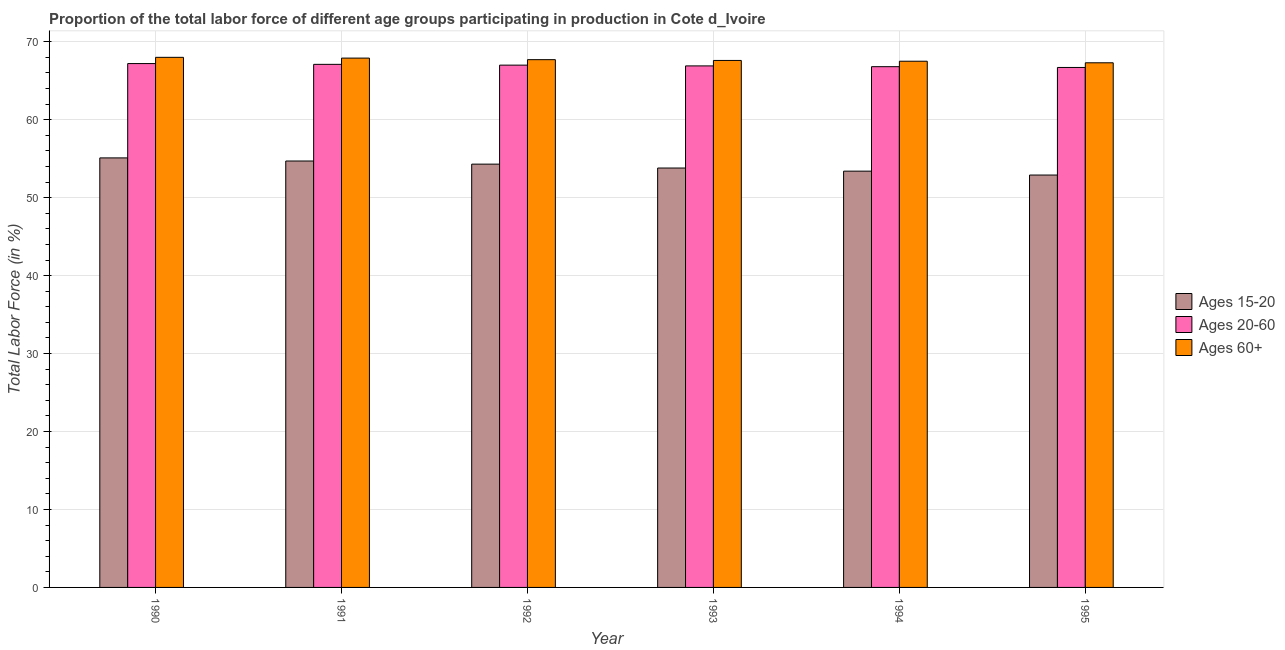Are the number of bars per tick equal to the number of legend labels?
Your response must be concise. Yes. How many bars are there on the 6th tick from the left?
Your answer should be compact. 3. In how many cases, is the number of bars for a given year not equal to the number of legend labels?
Your answer should be very brief. 0. What is the percentage of labor force within the age group 15-20 in 1994?
Keep it short and to the point. 53.4. Across all years, what is the maximum percentage of labor force within the age group 20-60?
Provide a short and direct response. 67.2. Across all years, what is the minimum percentage of labor force above age 60?
Your answer should be compact. 67.3. What is the total percentage of labor force within the age group 15-20 in the graph?
Your answer should be compact. 324.2. What is the difference between the percentage of labor force within the age group 15-20 in 1990 and that in 1994?
Offer a very short reply. 1.7. What is the difference between the percentage of labor force above age 60 in 1991 and the percentage of labor force within the age group 20-60 in 1992?
Provide a short and direct response. 0.2. What is the average percentage of labor force above age 60 per year?
Offer a very short reply. 67.67. In how many years, is the percentage of labor force above age 60 greater than 32 %?
Your response must be concise. 6. What is the ratio of the percentage of labor force above age 60 in 1993 to that in 1994?
Offer a very short reply. 1. Is the percentage of labor force within the age group 20-60 in 1991 less than that in 1993?
Offer a terse response. No. What is the difference between the highest and the second highest percentage of labor force above age 60?
Ensure brevity in your answer.  0.1. What is the difference between the highest and the lowest percentage of labor force within the age group 15-20?
Make the answer very short. 2.2. In how many years, is the percentage of labor force within the age group 15-20 greater than the average percentage of labor force within the age group 15-20 taken over all years?
Offer a very short reply. 3. Is the sum of the percentage of labor force within the age group 20-60 in 1994 and 1995 greater than the maximum percentage of labor force within the age group 15-20 across all years?
Ensure brevity in your answer.  Yes. What does the 2nd bar from the left in 1994 represents?
Ensure brevity in your answer.  Ages 20-60. What does the 1st bar from the right in 1994 represents?
Ensure brevity in your answer.  Ages 60+. How many years are there in the graph?
Your answer should be compact. 6. Are the values on the major ticks of Y-axis written in scientific E-notation?
Keep it short and to the point. No. Does the graph contain any zero values?
Offer a very short reply. No. Does the graph contain grids?
Give a very brief answer. Yes. How many legend labels are there?
Offer a very short reply. 3. How are the legend labels stacked?
Your answer should be very brief. Vertical. What is the title of the graph?
Ensure brevity in your answer.  Proportion of the total labor force of different age groups participating in production in Cote d_Ivoire. What is the label or title of the X-axis?
Offer a terse response. Year. What is the Total Labor Force (in %) in Ages 15-20 in 1990?
Offer a terse response. 55.1. What is the Total Labor Force (in %) of Ages 20-60 in 1990?
Provide a short and direct response. 67.2. What is the Total Labor Force (in %) in Ages 60+ in 1990?
Your answer should be compact. 68. What is the Total Labor Force (in %) in Ages 15-20 in 1991?
Provide a succinct answer. 54.7. What is the Total Labor Force (in %) of Ages 20-60 in 1991?
Offer a very short reply. 67.1. What is the Total Labor Force (in %) in Ages 60+ in 1991?
Keep it short and to the point. 67.9. What is the Total Labor Force (in %) of Ages 15-20 in 1992?
Make the answer very short. 54.3. What is the Total Labor Force (in %) of Ages 20-60 in 1992?
Offer a terse response. 67. What is the Total Labor Force (in %) of Ages 60+ in 1992?
Make the answer very short. 67.7. What is the Total Labor Force (in %) of Ages 15-20 in 1993?
Offer a very short reply. 53.8. What is the Total Labor Force (in %) in Ages 20-60 in 1993?
Ensure brevity in your answer.  66.9. What is the Total Labor Force (in %) in Ages 60+ in 1993?
Provide a succinct answer. 67.6. What is the Total Labor Force (in %) of Ages 15-20 in 1994?
Provide a succinct answer. 53.4. What is the Total Labor Force (in %) in Ages 20-60 in 1994?
Your answer should be very brief. 66.8. What is the Total Labor Force (in %) in Ages 60+ in 1994?
Your answer should be compact. 67.5. What is the Total Labor Force (in %) of Ages 15-20 in 1995?
Your answer should be compact. 52.9. What is the Total Labor Force (in %) in Ages 20-60 in 1995?
Your answer should be very brief. 66.7. What is the Total Labor Force (in %) of Ages 60+ in 1995?
Keep it short and to the point. 67.3. Across all years, what is the maximum Total Labor Force (in %) in Ages 15-20?
Ensure brevity in your answer.  55.1. Across all years, what is the maximum Total Labor Force (in %) of Ages 20-60?
Keep it short and to the point. 67.2. Across all years, what is the minimum Total Labor Force (in %) of Ages 15-20?
Your response must be concise. 52.9. Across all years, what is the minimum Total Labor Force (in %) of Ages 20-60?
Your response must be concise. 66.7. Across all years, what is the minimum Total Labor Force (in %) in Ages 60+?
Give a very brief answer. 67.3. What is the total Total Labor Force (in %) in Ages 15-20 in the graph?
Make the answer very short. 324.2. What is the total Total Labor Force (in %) of Ages 20-60 in the graph?
Make the answer very short. 401.7. What is the total Total Labor Force (in %) of Ages 60+ in the graph?
Offer a very short reply. 406. What is the difference between the Total Labor Force (in %) of Ages 15-20 in 1990 and that in 1991?
Your response must be concise. 0.4. What is the difference between the Total Labor Force (in %) of Ages 60+ in 1990 and that in 1991?
Your answer should be compact. 0.1. What is the difference between the Total Labor Force (in %) of Ages 15-20 in 1990 and that in 1992?
Make the answer very short. 0.8. What is the difference between the Total Labor Force (in %) of Ages 60+ in 1990 and that in 1992?
Provide a succinct answer. 0.3. What is the difference between the Total Labor Force (in %) in Ages 15-20 in 1990 and that in 1993?
Make the answer very short. 1.3. What is the difference between the Total Labor Force (in %) of Ages 60+ in 1990 and that in 1993?
Make the answer very short. 0.4. What is the difference between the Total Labor Force (in %) of Ages 15-20 in 1990 and that in 1994?
Make the answer very short. 1.7. What is the difference between the Total Labor Force (in %) of Ages 15-20 in 1990 and that in 1995?
Make the answer very short. 2.2. What is the difference between the Total Labor Force (in %) of Ages 20-60 in 1990 and that in 1995?
Provide a short and direct response. 0.5. What is the difference between the Total Labor Force (in %) in Ages 20-60 in 1991 and that in 1992?
Your response must be concise. 0.1. What is the difference between the Total Labor Force (in %) in Ages 60+ in 1991 and that in 1992?
Your answer should be very brief. 0.2. What is the difference between the Total Labor Force (in %) in Ages 15-20 in 1991 and that in 1993?
Provide a short and direct response. 0.9. What is the difference between the Total Labor Force (in %) of Ages 20-60 in 1991 and that in 1993?
Your response must be concise. 0.2. What is the difference between the Total Labor Force (in %) in Ages 60+ in 1991 and that in 1993?
Your response must be concise. 0.3. What is the difference between the Total Labor Force (in %) of Ages 60+ in 1991 and that in 1994?
Provide a succinct answer. 0.4. What is the difference between the Total Labor Force (in %) in Ages 20-60 in 1991 and that in 1995?
Ensure brevity in your answer.  0.4. What is the difference between the Total Labor Force (in %) in Ages 60+ in 1992 and that in 1993?
Ensure brevity in your answer.  0.1. What is the difference between the Total Labor Force (in %) in Ages 20-60 in 1992 and that in 1994?
Your answer should be very brief. 0.2. What is the difference between the Total Labor Force (in %) of Ages 60+ in 1992 and that in 1995?
Give a very brief answer. 0.4. What is the difference between the Total Labor Force (in %) of Ages 20-60 in 1993 and that in 1994?
Offer a terse response. 0.1. What is the difference between the Total Labor Force (in %) of Ages 20-60 in 1993 and that in 1995?
Your answer should be very brief. 0.2. What is the difference between the Total Labor Force (in %) in Ages 15-20 in 1990 and the Total Labor Force (in %) in Ages 20-60 in 1991?
Your answer should be compact. -12. What is the difference between the Total Labor Force (in %) in Ages 20-60 in 1990 and the Total Labor Force (in %) in Ages 60+ in 1991?
Your response must be concise. -0.7. What is the difference between the Total Labor Force (in %) in Ages 15-20 in 1990 and the Total Labor Force (in %) in Ages 20-60 in 1993?
Make the answer very short. -11.8. What is the difference between the Total Labor Force (in %) in Ages 15-20 in 1990 and the Total Labor Force (in %) in Ages 60+ in 1993?
Offer a terse response. -12.5. What is the difference between the Total Labor Force (in %) in Ages 20-60 in 1990 and the Total Labor Force (in %) in Ages 60+ in 1993?
Keep it short and to the point. -0.4. What is the difference between the Total Labor Force (in %) in Ages 15-20 in 1990 and the Total Labor Force (in %) in Ages 20-60 in 1995?
Provide a short and direct response. -11.6. What is the difference between the Total Labor Force (in %) in Ages 15-20 in 1990 and the Total Labor Force (in %) in Ages 60+ in 1995?
Offer a terse response. -12.2. What is the difference between the Total Labor Force (in %) in Ages 20-60 in 1990 and the Total Labor Force (in %) in Ages 60+ in 1995?
Your response must be concise. -0.1. What is the difference between the Total Labor Force (in %) in Ages 20-60 in 1991 and the Total Labor Force (in %) in Ages 60+ in 1993?
Provide a succinct answer. -0.5. What is the difference between the Total Labor Force (in %) of Ages 15-20 in 1991 and the Total Labor Force (in %) of Ages 20-60 in 1994?
Provide a short and direct response. -12.1. What is the difference between the Total Labor Force (in %) of Ages 15-20 in 1991 and the Total Labor Force (in %) of Ages 60+ in 1994?
Your answer should be compact. -12.8. What is the difference between the Total Labor Force (in %) of Ages 15-20 in 1991 and the Total Labor Force (in %) of Ages 20-60 in 1995?
Provide a succinct answer. -12. What is the difference between the Total Labor Force (in %) of Ages 15-20 in 1991 and the Total Labor Force (in %) of Ages 60+ in 1995?
Your answer should be compact. -12.6. What is the difference between the Total Labor Force (in %) in Ages 20-60 in 1991 and the Total Labor Force (in %) in Ages 60+ in 1995?
Offer a very short reply. -0.2. What is the difference between the Total Labor Force (in %) of Ages 15-20 in 1992 and the Total Labor Force (in %) of Ages 60+ in 1993?
Your answer should be very brief. -13.3. What is the difference between the Total Labor Force (in %) in Ages 15-20 in 1992 and the Total Labor Force (in %) in Ages 60+ in 1994?
Ensure brevity in your answer.  -13.2. What is the difference between the Total Labor Force (in %) of Ages 15-20 in 1992 and the Total Labor Force (in %) of Ages 60+ in 1995?
Provide a short and direct response. -13. What is the difference between the Total Labor Force (in %) of Ages 15-20 in 1993 and the Total Labor Force (in %) of Ages 20-60 in 1994?
Give a very brief answer. -13. What is the difference between the Total Labor Force (in %) of Ages 15-20 in 1993 and the Total Labor Force (in %) of Ages 60+ in 1994?
Provide a short and direct response. -13.7. What is the difference between the Total Labor Force (in %) in Ages 20-60 in 1993 and the Total Labor Force (in %) in Ages 60+ in 1994?
Ensure brevity in your answer.  -0.6. What is the difference between the Total Labor Force (in %) in Ages 15-20 in 1993 and the Total Labor Force (in %) in Ages 60+ in 1995?
Ensure brevity in your answer.  -13.5. What is the difference between the Total Labor Force (in %) of Ages 15-20 in 1994 and the Total Labor Force (in %) of Ages 20-60 in 1995?
Your answer should be compact. -13.3. What is the difference between the Total Labor Force (in %) of Ages 15-20 in 1994 and the Total Labor Force (in %) of Ages 60+ in 1995?
Keep it short and to the point. -13.9. What is the difference between the Total Labor Force (in %) of Ages 20-60 in 1994 and the Total Labor Force (in %) of Ages 60+ in 1995?
Keep it short and to the point. -0.5. What is the average Total Labor Force (in %) in Ages 15-20 per year?
Ensure brevity in your answer.  54.03. What is the average Total Labor Force (in %) in Ages 20-60 per year?
Keep it short and to the point. 66.95. What is the average Total Labor Force (in %) of Ages 60+ per year?
Offer a very short reply. 67.67. In the year 1990, what is the difference between the Total Labor Force (in %) in Ages 15-20 and Total Labor Force (in %) in Ages 60+?
Your answer should be very brief. -12.9. In the year 1990, what is the difference between the Total Labor Force (in %) of Ages 20-60 and Total Labor Force (in %) of Ages 60+?
Keep it short and to the point. -0.8. In the year 1991, what is the difference between the Total Labor Force (in %) of Ages 15-20 and Total Labor Force (in %) of Ages 20-60?
Keep it short and to the point. -12.4. In the year 1991, what is the difference between the Total Labor Force (in %) in Ages 20-60 and Total Labor Force (in %) in Ages 60+?
Provide a succinct answer. -0.8. In the year 1992, what is the difference between the Total Labor Force (in %) in Ages 15-20 and Total Labor Force (in %) in Ages 20-60?
Your answer should be very brief. -12.7. In the year 1992, what is the difference between the Total Labor Force (in %) of Ages 15-20 and Total Labor Force (in %) of Ages 60+?
Provide a succinct answer. -13.4. In the year 1992, what is the difference between the Total Labor Force (in %) of Ages 20-60 and Total Labor Force (in %) of Ages 60+?
Your answer should be compact. -0.7. In the year 1993, what is the difference between the Total Labor Force (in %) in Ages 15-20 and Total Labor Force (in %) in Ages 60+?
Your answer should be compact. -13.8. In the year 1993, what is the difference between the Total Labor Force (in %) of Ages 20-60 and Total Labor Force (in %) of Ages 60+?
Ensure brevity in your answer.  -0.7. In the year 1994, what is the difference between the Total Labor Force (in %) of Ages 15-20 and Total Labor Force (in %) of Ages 20-60?
Provide a short and direct response. -13.4. In the year 1994, what is the difference between the Total Labor Force (in %) in Ages 15-20 and Total Labor Force (in %) in Ages 60+?
Keep it short and to the point. -14.1. In the year 1994, what is the difference between the Total Labor Force (in %) in Ages 20-60 and Total Labor Force (in %) in Ages 60+?
Provide a short and direct response. -0.7. In the year 1995, what is the difference between the Total Labor Force (in %) of Ages 15-20 and Total Labor Force (in %) of Ages 20-60?
Ensure brevity in your answer.  -13.8. In the year 1995, what is the difference between the Total Labor Force (in %) of Ages 15-20 and Total Labor Force (in %) of Ages 60+?
Your response must be concise. -14.4. In the year 1995, what is the difference between the Total Labor Force (in %) in Ages 20-60 and Total Labor Force (in %) in Ages 60+?
Ensure brevity in your answer.  -0.6. What is the ratio of the Total Labor Force (in %) of Ages 15-20 in 1990 to that in 1991?
Offer a very short reply. 1.01. What is the ratio of the Total Labor Force (in %) of Ages 15-20 in 1990 to that in 1992?
Your answer should be compact. 1.01. What is the ratio of the Total Labor Force (in %) of Ages 60+ in 1990 to that in 1992?
Offer a terse response. 1. What is the ratio of the Total Labor Force (in %) of Ages 15-20 in 1990 to that in 1993?
Offer a terse response. 1.02. What is the ratio of the Total Labor Force (in %) of Ages 20-60 in 1990 to that in 1993?
Keep it short and to the point. 1. What is the ratio of the Total Labor Force (in %) in Ages 60+ in 1990 to that in 1993?
Give a very brief answer. 1.01. What is the ratio of the Total Labor Force (in %) in Ages 15-20 in 1990 to that in 1994?
Your answer should be very brief. 1.03. What is the ratio of the Total Labor Force (in %) of Ages 60+ in 1990 to that in 1994?
Keep it short and to the point. 1.01. What is the ratio of the Total Labor Force (in %) in Ages 15-20 in 1990 to that in 1995?
Your response must be concise. 1.04. What is the ratio of the Total Labor Force (in %) in Ages 20-60 in 1990 to that in 1995?
Offer a very short reply. 1.01. What is the ratio of the Total Labor Force (in %) in Ages 60+ in 1990 to that in 1995?
Your response must be concise. 1.01. What is the ratio of the Total Labor Force (in %) in Ages 15-20 in 1991 to that in 1992?
Your answer should be compact. 1.01. What is the ratio of the Total Labor Force (in %) of Ages 20-60 in 1991 to that in 1992?
Offer a very short reply. 1. What is the ratio of the Total Labor Force (in %) in Ages 15-20 in 1991 to that in 1993?
Ensure brevity in your answer.  1.02. What is the ratio of the Total Labor Force (in %) in Ages 20-60 in 1991 to that in 1993?
Offer a very short reply. 1. What is the ratio of the Total Labor Force (in %) of Ages 15-20 in 1991 to that in 1994?
Your answer should be compact. 1.02. What is the ratio of the Total Labor Force (in %) in Ages 20-60 in 1991 to that in 1994?
Keep it short and to the point. 1. What is the ratio of the Total Labor Force (in %) of Ages 60+ in 1991 to that in 1994?
Provide a short and direct response. 1.01. What is the ratio of the Total Labor Force (in %) in Ages 15-20 in 1991 to that in 1995?
Give a very brief answer. 1.03. What is the ratio of the Total Labor Force (in %) of Ages 20-60 in 1991 to that in 1995?
Your answer should be compact. 1.01. What is the ratio of the Total Labor Force (in %) of Ages 60+ in 1991 to that in 1995?
Provide a succinct answer. 1.01. What is the ratio of the Total Labor Force (in %) of Ages 15-20 in 1992 to that in 1993?
Your answer should be very brief. 1.01. What is the ratio of the Total Labor Force (in %) in Ages 20-60 in 1992 to that in 1993?
Provide a succinct answer. 1. What is the ratio of the Total Labor Force (in %) of Ages 15-20 in 1992 to that in 1994?
Offer a terse response. 1.02. What is the ratio of the Total Labor Force (in %) in Ages 15-20 in 1992 to that in 1995?
Offer a terse response. 1.03. What is the ratio of the Total Labor Force (in %) of Ages 60+ in 1992 to that in 1995?
Keep it short and to the point. 1.01. What is the ratio of the Total Labor Force (in %) of Ages 15-20 in 1993 to that in 1994?
Offer a terse response. 1.01. What is the ratio of the Total Labor Force (in %) of Ages 15-20 in 1993 to that in 1995?
Your answer should be very brief. 1.02. What is the ratio of the Total Labor Force (in %) in Ages 15-20 in 1994 to that in 1995?
Offer a terse response. 1.01. What is the ratio of the Total Labor Force (in %) of Ages 60+ in 1994 to that in 1995?
Your answer should be very brief. 1. What is the difference between the highest and the second highest Total Labor Force (in %) of Ages 15-20?
Offer a very short reply. 0.4. What is the difference between the highest and the second highest Total Labor Force (in %) in Ages 20-60?
Provide a succinct answer. 0.1. What is the difference between the highest and the lowest Total Labor Force (in %) of Ages 15-20?
Keep it short and to the point. 2.2. What is the difference between the highest and the lowest Total Labor Force (in %) in Ages 20-60?
Ensure brevity in your answer.  0.5. What is the difference between the highest and the lowest Total Labor Force (in %) of Ages 60+?
Keep it short and to the point. 0.7. 